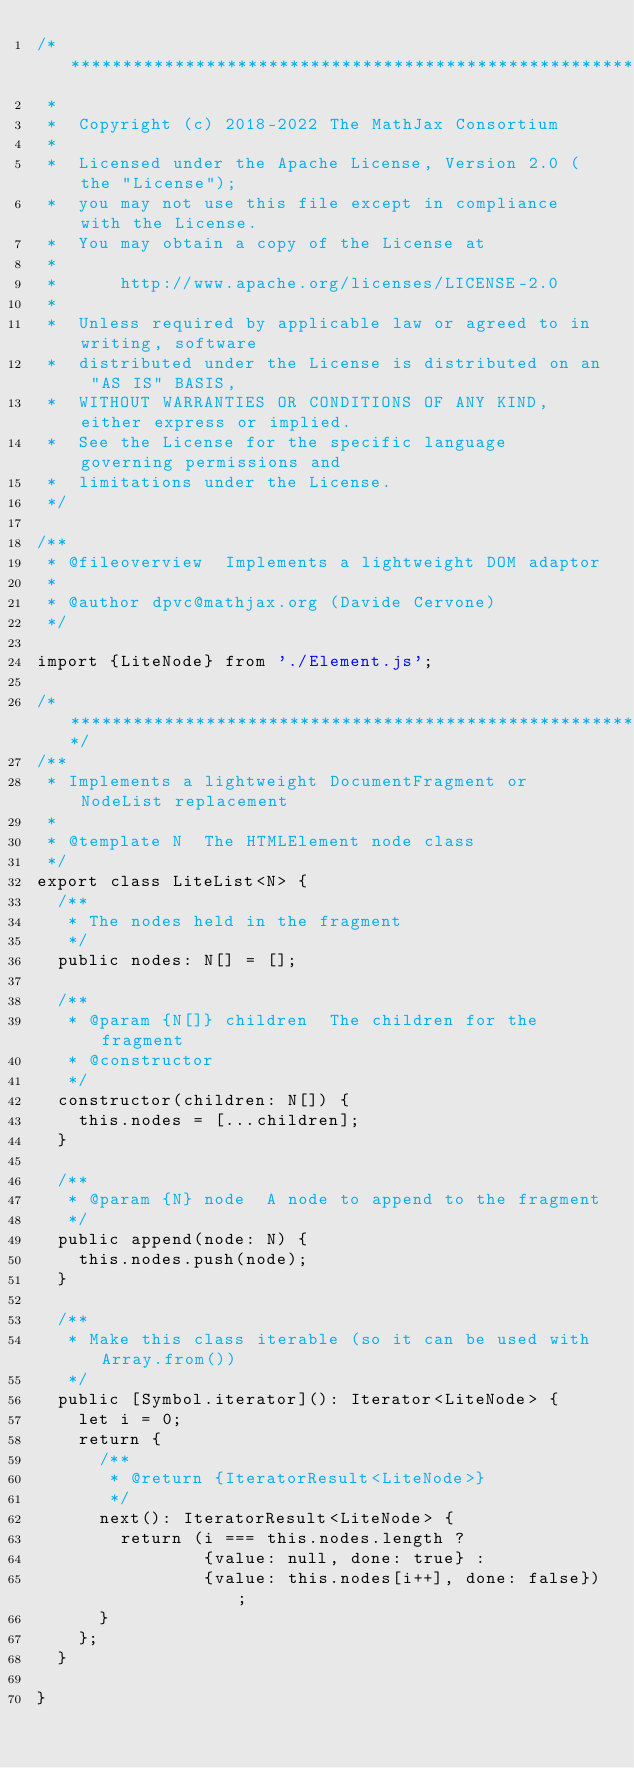<code> <loc_0><loc_0><loc_500><loc_500><_TypeScript_>/*************************************************************
 *
 *  Copyright (c) 2018-2022 The MathJax Consortium
 *
 *  Licensed under the Apache License, Version 2.0 (the "License");
 *  you may not use this file except in compliance with the License.
 *  You may obtain a copy of the License at
 *
 *      http://www.apache.org/licenses/LICENSE-2.0
 *
 *  Unless required by applicable law or agreed to in writing, software
 *  distributed under the License is distributed on an "AS IS" BASIS,
 *  WITHOUT WARRANTIES OR CONDITIONS OF ANY KIND, either express or implied.
 *  See the License for the specific language governing permissions and
 *  limitations under the License.
 */

/**
 * @fileoverview  Implements a lightweight DOM adaptor
 *
 * @author dpvc@mathjax.org (Davide Cervone)
 */

import {LiteNode} from './Element.js';

/************************************************************/
/**
 * Implements a lightweight DocumentFragment or NodeList replacement
 *
 * @template N  The HTMLElement node class
 */
export class LiteList<N> {
  /**
   * The nodes held in the fragment
   */
  public nodes: N[] = [];

  /**
   * @param {N[]} children  The children for the fragment
   * @constructor
   */
  constructor(children: N[]) {
    this.nodes = [...children];
  }

  /**
   * @param {N} node  A node to append to the fragment
   */
  public append(node: N) {
    this.nodes.push(node);
  }

  /**
   * Make this class iterable (so it can be used with Array.from())
   */
  public [Symbol.iterator](): Iterator<LiteNode> {
    let i = 0;
    return {
      /**
       * @return {IteratorResult<LiteNode>}
       */
      next(): IteratorResult<LiteNode> {
        return (i === this.nodes.length ?
                {value: null, done: true} :
                {value: this.nodes[i++], done: false});
      }
    };
  }

}
</code> 